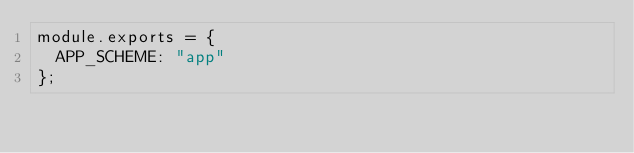<code> <loc_0><loc_0><loc_500><loc_500><_JavaScript_>module.exports = {
  APP_SCHEME: "app"
};
</code> 